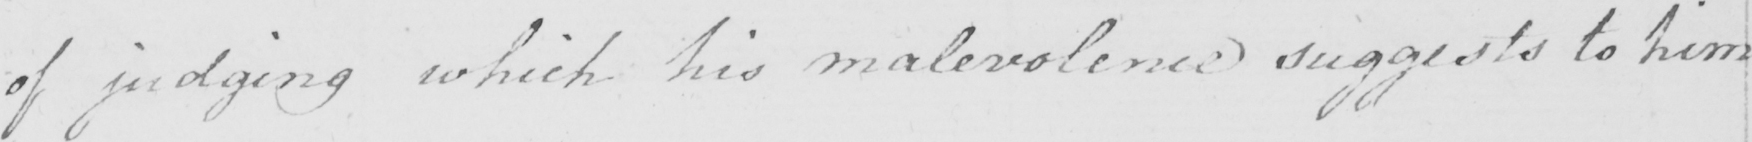Please transcribe the handwritten text in this image. of judging which his malevolence suggests to him 